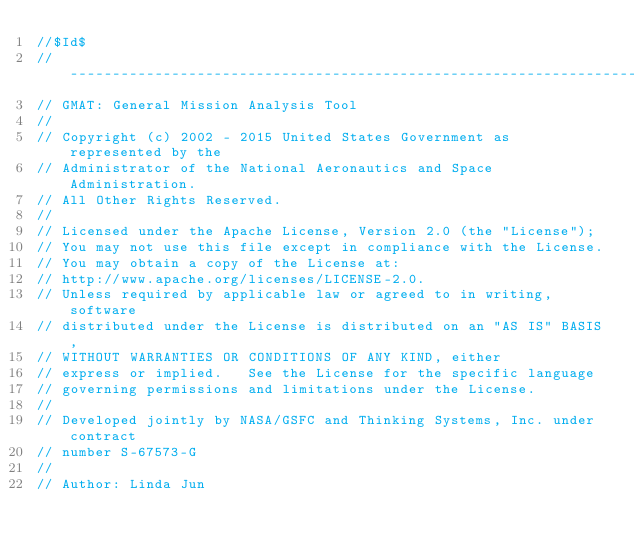<code> <loc_0><loc_0><loc_500><loc_500><_C++_>//$Id$
//------------------------------------------------------------------------------
// GMAT: General Mission Analysis Tool
// 
// Copyright (c) 2002 - 2015 United States Government as represented by the
// Administrator of the National Aeronautics and Space Administration.
// All Other Rights Reserved.
//
// Licensed under the Apache License, Version 2.0 (the "License"); 
// You may not use this file except in compliance with the License. 
// You may obtain a copy of the License at:
// http://www.apache.org/licenses/LICENSE-2.0. 
// Unless required by applicable law or agreed to in writing, software
// distributed under the License is distributed on an "AS IS" BASIS,
// WITHOUT WARRANTIES OR CONDITIONS OF ANY KIND, either 
// express or implied.   See the License for the specific language
// governing permissions and limitations under the License.
//
// Developed jointly by NASA/GSFC and Thinking Systems, Inc. under contract
// number S-67573-G
//
// Author: Linda Jun</code> 